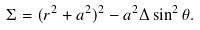Convert formula to latex. <formula><loc_0><loc_0><loc_500><loc_500>\Sigma = ( r ^ { 2 } + a ^ { 2 } ) ^ { 2 } - a ^ { 2 } \Delta \sin ^ { 2 } \theta .</formula> 